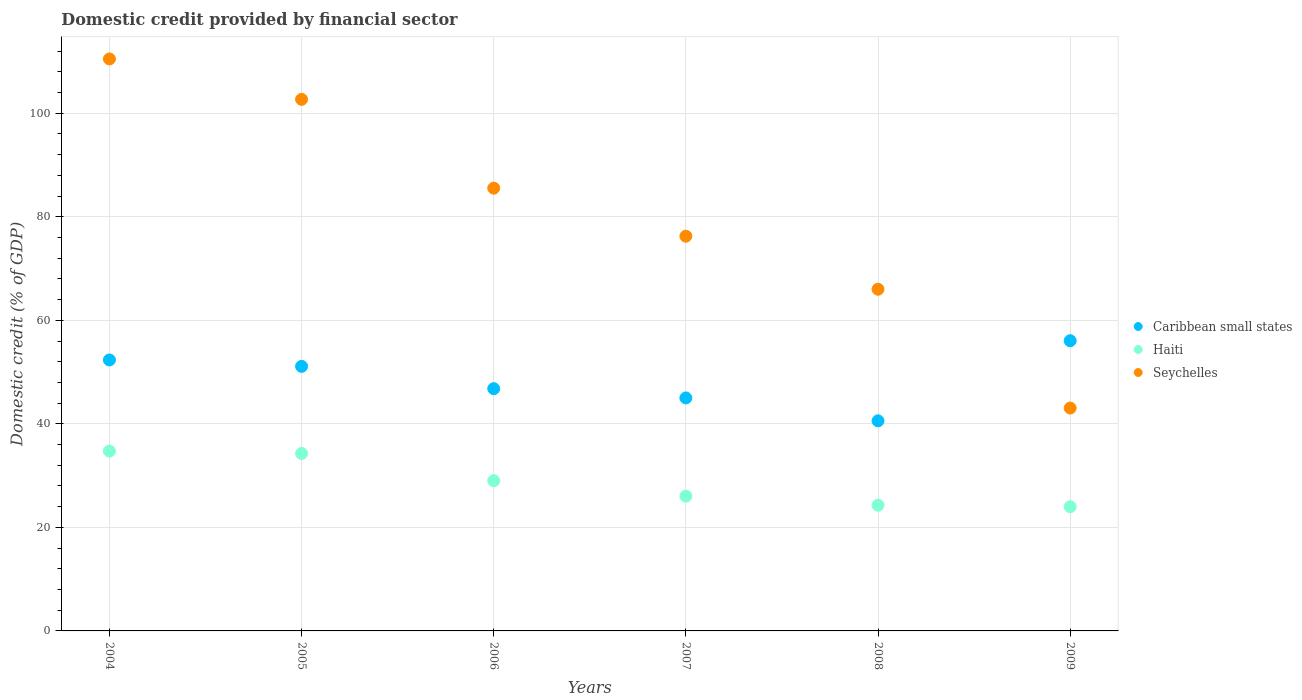What is the domestic credit in Seychelles in 2009?
Offer a terse response. 43.05. Across all years, what is the maximum domestic credit in Caribbean small states?
Make the answer very short. 56.06. Across all years, what is the minimum domestic credit in Caribbean small states?
Give a very brief answer. 40.58. In which year was the domestic credit in Caribbean small states maximum?
Your answer should be very brief. 2009. In which year was the domestic credit in Seychelles minimum?
Provide a succinct answer. 2009. What is the total domestic credit in Caribbean small states in the graph?
Your response must be concise. 291.91. What is the difference between the domestic credit in Caribbean small states in 2006 and that in 2009?
Make the answer very short. -9.26. What is the difference between the domestic credit in Caribbean small states in 2006 and the domestic credit in Seychelles in 2007?
Give a very brief answer. -29.45. What is the average domestic credit in Haiti per year?
Keep it short and to the point. 28.73. In the year 2008, what is the difference between the domestic credit in Seychelles and domestic credit in Caribbean small states?
Offer a very short reply. 25.42. In how many years, is the domestic credit in Haiti greater than 108 %?
Your answer should be compact. 0. What is the ratio of the domestic credit in Seychelles in 2004 to that in 2008?
Offer a terse response. 1.67. What is the difference between the highest and the second highest domestic credit in Seychelles?
Provide a short and direct response. 7.8. What is the difference between the highest and the lowest domestic credit in Haiti?
Keep it short and to the point. 10.75. Does the domestic credit in Seychelles monotonically increase over the years?
Offer a very short reply. No. Is the domestic credit in Caribbean small states strictly greater than the domestic credit in Seychelles over the years?
Make the answer very short. No. How many dotlines are there?
Keep it short and to the point. 3. How many years are there in the graph?
Offer a terse response. 6. Does the graph contain grids?
Ensure brevity in your answer.  Yes. How many legend labels are there?
Make the answer very short. 3. How are the legend labels stacked?
Make the answer very short. Vertical. What is the title of the graph?
Offer a terse response. Domestic credit provided by financial sector. What is the label or title of the Y-axis?
Make the answer very short. Domestic credit (% of GDP). What is the Domestic credit (% of GDP) of Caribbean small states in 2004?
Provide a short and direct response. 52.34. What is the Domestic credit (% of GDP) of Haiti in 2004?
Keep it short and to the point. 34.74. What is the Domestic credit (% of GDP) of Seychelles in 2004?
Ensure brevity in your answer.  110.49. What is the Domestic credit (% of GDP) of Caribbean small states in 2005?
Keep it short and to the point. 51.11. What is the Domestic credit (% of GDP) of Haiti in 2005?
Keep it short and to the point. 34.29. What is the Domestic credit (% of GDP) of Seychelles in 2005?
Provide a succinct answer. 102.69. What is the Domestic credit (% of GDP) of Caribbean small states in 2006?
Provide a succinct answer. 46.8. What is the Domestic credit (% of GDP) of Haiti in 2006?
Offer a very short reply. 29.02. What is the Domestic credit (% of GDP) of Seychelles in 2006?
Give a very brief answer. 85.53. What is the Domestic credit (% of GDP) in Caribbean small states in 2007?
Your answer should be very brief. 45.01. What is the Domestic credit (% of GDP) in Haiti in 2007?
Ensure brevity in your answer.  26.04. What is the Domestic credit (% of GDP) in Seychelles in 2007?
Give a very brief answer. 76.25. What is the Domestic credit (% of GDP) of Caribbean small states in 2008?
Provide a short and direct response. 40.58. What is the Domestic credit (% of GDP) in Haiti in 2008?
Your answer should be compact. 24.28. What is the Domestic credit (% of GDP) in Seychelles in 2008?
Your answer should be compact. 66. What is the Domestic credit (% of GDP) in Caribbean small states in 2009?
Ensure brevity in your answer.  56.06. What is the Domestic credit (% of GDP) of Haiti in 2009?
Ensure brevity in your answer.  24. What is the Domestic credit (% of GDP) in Seychelles in 2009?
Give a very brief answer. 43.05. Across all years, what is the maximum Domestic credit (% of GDP) of Caribbean small states?
Offer a terse response. 56.06. Across all years, what is the maximum Domestic credit (% of GDP) of Haiti?
Your response must be concise. 34.74. Across all years, what is the maximum Domestic credit (% of GDP) of Seychelles?
Your answer should be very brief. 110.49. Across all years, what is the minimum Domestic credit (% of GDP) of Caribbean small states?
Your answer should be very brief. 40.58. Across all years, what is the minimum Domestic credit (% of GDP) in Haiti?
Your answer should be compact. 24. Across all years, what is the minimum Domestic credit (% of GDP) in Seychelles?
Keep it short and to the point. 43.05. What is the total Domestic credit (% of GDP) of Caribbean small states in the graph?
Your answer should be compact. 291.91. What is the total Domestic credit (% of GDP) in Haiti in the graph?
Offer a terse response. 172.36. What is the total Domestic credit (% of GDP) of Seychelles in the graph?
Your answer should be compact. 484.02. What is the difference between the Domestic credit (% of GDP) of Caribbean small states in 2004 and that in 2005?
Offer a terse response. 1.24. What is the difference between the Domestic credit (% of GDP) of Haiti in 2004 and that in 2005?
Make the answer very short. 0.46. What is the difference between the Domestic credit (% of GDP) in Seychelles in 2004 and that in 2005?
Provide a short and direct response. 7.8. What is the difference between the Domestic credit (% of GDP) of Caribbean small states in 2004 and that in 2006?
Keep it short and to the point. 5.54. What is the difference between the Domestic credit (% of GDP) in Haiti in 2004 and that in 2006?
Make the answer very short. 5.72. What is the difference between the Domestic credit (% of GDP) in Seychelles in 2004 and that in 2006?
Provide a succinct answer. 24.96. What is the difference between the Domestic credit (% of GDP) of Caribbean small states in 2004 and that in 2007?
Provide a succinct answer. 7.34. What is the difference between the Domestic credit (% of GDP) in Haiti in 2004 and that in 2007?
Your answer should be very brief. 8.71. What is the difference between the Domestic credit (% of GDP) in Seychelles in 2004 and that in 2007?
Make the answer very short. 34.24. What is the difference between the Domestic credit (% of GDP) of Caribbean small states in 2004 and that in 2008?
Your answer should be compact. 11.76. What is the difference between the Domestic credit (% of GDP) of Haiti in 2004 and that in 2008?
Offer a terse response. 10.47. What is the difference between the Domestic credit (% of GDP) in Seychelles in 2004 and that in 2008?
Provide a succinct answer. 44.49. What is the difference between the Domestic credit (% of GDP) of Caribbean small states in 2004 and that in 2009?
Your response must be concise. -3.72. What is the difference between the Domestic credit (% of GDP) in Haiti in 2004 and that in 2009?
Provide a succinct answer. 10.75. What is the difference between the Domestic credit (% of GDP) in Seychelles in 2004 and that in 2009?
Your answer should be very brief. 67.44. What is the difference between the Domestic credit (% of GDP) in Caribbean small states in 2005 and that in 2006?
Offer a very short reply. 4.31. What is the difference between the Domestic credit (% of GDP) in Haiti in 2005 and that in 2006?
Offer a terse response. 5.26. What is the difference between the Domestic credit (% of GDP) of Seychelles in 2005 and that in 2006?
Offer a terse response. 17.16. What is the difference between the Domestic credit (% of GDP) of Caribbean small states in 2005 and that in 2007?
Keep it short and to the point. 6.1. What is the difference between the Domestic credit (% of GDP) in Haiti in 2005 and that in 2007?
Provide a short and direct response. 8.25. What is the difference between the Domestic credit (% of GDP) in Seychelles in 2005 and that in 2007?
Keep it short and to the point. 26.44. What is the difference between the Domestic credit (% of GDP) in Caribbean small states in 2005 and that in 2008?
Offer a very short reply. 10.52. What is the difference between the Domestic credit (% of GDP) of Haiti in 2005 and that in 2008?
Offer a very short reply. 10.01. What is the difference between the Domestic credit (% of GDP) in Seychelles in 2005 and that in 2008?
Offer a terse response. 36.69. What is the difference between the Domestic credit (% of GDP) in Caribbean small states in 2005 and that in 2009?
Provide a succinct answer. -4.96. What is the difference between the Domestic credit (% of GDP) of Haiti in 2005 and that in 2009?
Make the answer very short. 10.29. What is the difference between the Domestic credit (% of GDP) of Seychelles in 2005 and that in 2009?
Your response must be concise. 59.64. What is the difference between the Domestic credit (% of GDP) in Caribbean small states in 2006 and that in 2007?
Make the answer very short. 1.79. What is the difference between the Domestic credit (% of GDP) in Haiti in 2006 and that in 2007?
Offer a very short reply. 2.99. What is the difference between the Domestic credit (% of GDP) of Seychelles in 2006 and that in 2007?
Ensure brevity in your answer.  9.28. What is the difference between the Domestic credit (% of GDP) of Caribbean small states in 2006 and that in 2008?
Give a very brief answer. 6.22. What is the difference between the Domestic credit (% of GDP) of Haiti in 2006 and that in 2008?
Provide a short and direct response. 4.75. What is the difference between the Domestic credit (% of GDP) in Seychelles in 2006 and that in 2008?
Offer a terse response. 19.53. What is the difference between the Domestic credit (% of GDP) in Caribbean small states in 2006 and that in 2009?
Ensure brevity in your answer.  -9.26. What is the difference between the Domestic credit (% of GDP) in Haiti in 2006 and that in 2009?
Your answer should be very brief. 5.03. What is the difference between the Domestic credit (% of GDP) of Seychelles in 2006 and that in 2009?
Provide a succinct answer. 42.48. What is the difference between the Domestic credit (% of GDP) of Caribbean small states in 2007 and that in 2008?
Offer a terse response. 4.42. What is the difference between the Domestic credit (% of GDP) in Haiti in 2007 and that in 2008?
Make the answer very short. 1.76. What is the difference between the Domestic credit (% of GDP) in Seychelles in 2007 and that in 2008?
Your answer should be very brief. 10.25. What is the difference between the Domestic credit (% of GDP) in Caribbean small states in 2007 and that in 2009?
Provide a succinct answer. -11.06. What is the difference between the Domestic credit (% of GDP) in Haiti in 2007 and that in 2009?
Keep it short and to the point. 2.04. What is the difference between the Domestic credit (% of GDP) in Seychelles in 2007 and that in 2009?
Provide a succinct answer. 33.2. What is the difference between the Domestic credit (% of GDP) in Caribbean small states in 2008 and that in 2009?
Provide a short and direct response. -15.48. What is the difference between the Domestic credit (% of GDP) of Haiti in 2008 and that in 2009?
Your answer should be very brief. 0.28. What is the difference between the Domestic credit (% of GDP) in Seychelles in 2008 and that in 2009?
Your answer should be compact. 22.95. What is the difference between the Domestic credit (% of GDP) of Caribbean small states in 2004 and the Domestic credit (% of GDP) of Haiti in 2005?
Give a very brief answer. 18.06. What is the difference between the Domestic credit (% of GDP) of Caribbean small states in 2004 and the Domestic credit (% of GDP) of Seychelles in 2005?
Offer a very short reply. -50.35. What is the difference between the Domestic credit (% of GDP) of Haiti in 2004 and the Domestic credit (% of GDP) of Seychelles in 2005?
Keep it short and to the point. -67.95. What is the difference between the Domestic credit (% of GDP) of Caribbean small states in 2004 and the Domestic credit (% of GDP) of Haiti in 2006?
Your answer should be compact. 23.32. What is the difference between the Domestic credit (% of GDP) of Caribbean small states in 2004 and the Domestic credit (% of GDP) of Seychelles in 2006?
Your answer should be compact. -33.19. What is the difference between the Domestic credit (% of GDP) of Haiti in 2004 and the Domestic credit (% of GDP) of Seychelles in 2006?
Your response must be concise. -50.79. What is the difference between the Domestic credit (% of GDP) in Caribbean small states in 2004 and the Domestic credit (% of GDP) in Haiti in 2007?
Make the answer very short. 26.31. What is the difference between the Domestic credit (% of GDP) of Caribbean small states in 2004 and the Domestic credit (% of GDP) of Seychelles in 2007?
Ensure brevity in your answer.  -23.91. What is the difference between the Domestic credit (% of GDP) of Haiti in 2004 and the Domestic credit (% of GDP) of Seychelles in 2007?
Provide a succinct answer. -41.51. What is the difference between the Domestic credit (% of GDP) in Caribbean small states in 2004 and the Domestic credit (% of GDP) in Haiti in 2008?
Your answer should be compact. 28.07. What is the difference between the Domestic credit (% of GDP) of Caribbean small states in 2004 and the Domestic credit (% of GDP) of Seychelles in 2008?
Give a very brief answer. -13.66. What is the difference between the Domestic credit (% of GDP) of Haiti in 2004 and the Domestic credit (% of GDP) of Seychelles in 2008?
Offer a very short reply. -31.26. What is the difference between the Domestic credit (% of GDP) of Caribbean small states in 2004 and the Domestic credit (% of GDP) of Haiti in 2009?
Offer a terse response. 28.35. What is the difference between the Domestic credit (% of GDP) in Caribbean small states in 2004 and the Domestic credit (% of GDP) in Seychelles in 2009?
Make the answer very short. 9.29. What is the difference between the Domestic credit (% of GDP) of Haiti in 2004 and the Domestic credit (% of GDP) of Seychelles in 2009?
Make the answer very short. -8.31. What is the difference between the Domestic credit (% of GDP) of Caribbean small states in 2005 and the Domestic credit (% of GDP) of Haiti in 2006?
Provide a succinct answer. 22.08. What is the difference between the Domestic credit (% of GDP) of Caribbean small states in 2005 and the Domestic credit (% of GDP) of Seychelles in 2006?
Provide a short and direct response. -34.42. What is the difference between the Domestic credit (% of GDP) of Haiti in 2005 and the Domestic credit (% of GDP) of Seychelles in 2006?
Ensure brevity in your answer.  -51.25. What is the difference between the Domestic credit (% of GDP) in Caribbean small states in 2005 and the Domestic credit (% of GDP) in Haiti in 2007?
Provide a succinct answer. 25.07. What is the difference between the Domestic credit (% of GDP) of Caribbean small states in 2005 and the Domestic credit (% of GDP) of Seychelles in 2007?
Give a very brief answer. -25.14. What is the difference between the Domestic credit (% of GDP) in Haiti in 2005 and the Domestic credit (% of GDP) in Seychelles in 2007?
Your answer should be compact. -41.97. What is the difference between the Domestic credit (% of GDP) in Caribbean small states in 2005 and the Domestic credit (% of GDP) in Haiti in 2008?
Your response must be concise. 26.83. What is the difference between the Domestic credit (% of GDP) of Caribbean small states in 2005 and the Domestic credit (% of GDP) of Seychelles in 2008?
Provide a succinct answer. -14.9. What is the difference between the Domestic credit (% of GDP) in Haiti in 2005 and the Domestic credit (% of GDP) in Seychelles in 2008?
Offer a terse response. -31.72. What is the difference between the Domestic credit (% of GDP) in Caribbean small states in 2005 and the Domestic credit (% of GDP) in Haiti in 2009?
Give a very brief answer. 27.11. What is the difference between the Domestic credit (% of GDP) in Caribbean small states in 2005 and the Domestic credit (% of GDP) in Seychelles in 2009?
Your answer should be compact. 8.05. What is the difference between the Domestic credit (% of GDP) of Haiti in 2005 and the Domestic credit (% of GDP) of Seychelles in 2009?
Your response must be concise. -8.77. What is the difference between the Domestic credit (% of GDP) in Caribbean small states in 2006 and the Domestic credit (% of GDP) in Haiti in 2007?
Give a very brief answer. 20.77. What is the difference between the Domestic credit (% of GDP) of Caribbean small states in 2006 and the Domestic credit (% of GDP) of Seychelles in 2007?
Provide a short and direct response. -29.45. What is the difference between the Domestic credit (% of GDP) of Haiti in 2006 and the Domestic credit (% of GDP) of Seychelles in 2007?
Ensure brevity in your answer.  -47.23. What is the difference between the Domestic credit (% of GDP) in Caribbean small states in 2006 and the Domestic credit (% of GDP) in Haiti in 2008?
Offer a very short reply. 22.53. What is the difference between the Domestic credit (% of GDP) of Caribbean small states in 2006 and the Domestic credit (% of GDP) of Seychelles in 2008?
Your response must be concise. -19.2. What is the difference between the Domestic credit (% of GDP) in Haiti in 2006 and the Domestic credit (% of GDP) in Seychelles in 2008?
Provide a short and direct response. -36.98. What is the difference between the Domestic credit (% of GDP) in Caribbean small states in 2006 and the Domestic credit (% of GDP) in Haiti in 2009?
Ensure brevity in your answer.  22.81. What is the difference between the Domestic credit (% of GDP) of Caribbean small states in 2006 and the Domestic credit (% of GDP) of Seychelles in 2009?
Offer a terse response. 3.75. What is the difference between the Domestic credit (% of GDP) of Haiti in 2006 and the Domestic credit (% of GDP) of Seychelles in 2009?
Your answer should be compact. -14.03. What is the difference between the Domestic credit (% of GDP) in Caribbean small states in 2007 and the Domestic credit (% of GDP) in Haiti in 2008?
Your answer should be very brief. 20.73. What is the difference between the Domestic credit (% of GDP) of Caribbean small states in 2007 and the Domestic credit (% of GDP) of Seychelles in 2008?
Make the answer very short. -21. What is the difference between the Domestic credit (% of GDP) in Haiti in 2007 and the Domestic credit (% of GDP) in Seychelles in 2008?
Offer a very short reply. -39.97. What is the difference between the Domestic credit (% of GDP) in Caribbean small states in 2007 and the Domestic credit (% of GDP) in Haiti in 2009?
Provide a succinct answer. 21.01. What is the difference between the Domestic credit (% of GDP) in Caribbean small states in 2007 and the Domestic credit (% of GDP) in Seychelles in 2009?
Your answer should be compact. 1.95. What is the difference between the Domestic credit (% of GDP) in Haiti in 2007 and the Domestic credit (% of GDP) in Seychelles in 2009?
Your response must be concise. -17.02. What is the difference between the Domestic credit (% of GDP) in Caribbean small states in 2008 and the Domestic credit (% of GDP) in Haiti in 2009?
Offer a terse response. 16.59. What is the difference between the Domestic credit (% of GDP) of Caribbean small states in 2008 and the Domestic credit (% of GDP) of Seychelles in 2009?
Offer a very short reply. -2.47. What is the difference between the Domestic credit (% of GDP) of Haiti in 2008 and the Domestic credit (% of GDP) of Seychelles in 2009?
Your answer should be very brief. -18.78. What is the average Domestic credit (% of GDP) of Caribbean small states per year?
Give a very brief answer. 48.65. What is the average Domestic credit (% of GDP) of Haiti per year?
Offer a very short reply. 28.73. What is the average Domestic credit (% of GDP) in Seychelles per year?
Keep it short and to the point. 80.67. In the year 2004, what is the difference between the Domestic credit (% of GDP) in Caribbean small states and Domestic credit (% of GDP) in Haiti?
Your response must be concise. 17.6. In the year 2004, what is the difference between the Domestic credit (% of GDP) of Caribbean small states and Domestic credit (% of GDP) of Seychelles?
Offer a terse response. -58.15. In the year 2004, what is the difference between the Domestic credit (% of GDP) of Haiti and Domestic credit (% of GDP) of Seychelles?
Keep it short and to the point. -75.75. In the year 2005, what is the difference between the Domestic credit (% of GDP) of Caribbean small states and Domestic credit (% of GDP) of Haiti?
Keep it short and to the point. 16.82. In the year 2005, what is the difference between the Domestic credit (% of GDP) in Caribbean small states and Domestic credit (% of GDP) in Seychelles?
Keep it short and to the point. -51.59. In the year 2005, what is the difference between the Domestic credit (% of GDP) of Haiti and Domestic credit (% of GDP) of Seychelles?
Ensure brevity in your answer.  -68.41. In the year 2006, what is the difference between the Domestic credit (% of GDP) of Caribbean small states and Domestic credit (% of GDP) of Haiti?
Ensure brevity in your answer.  17.78. In the year 2006, what is the difference between the Domestic credit (% of GDP) of Caribbean small states and Domestic credit (% of GDP) of Seychelles?
Keep it short and to the point. -38.73. In the year 2006, what is the difference between the Domestic credit (% of GDP) in Haiti and Domestic credit (% of GDP) in Seychelles?
Your response must be concise. -56.51. In the year 2007, what is the difference between the Domestic credit (% of GDP) in Caribbean small states and Domestic credit (% of GDP) in Haiti?
Your answer should be compact. 18.97. In the year 2007, what is the difference between the Domestic credit (% of GDP) in Caribbean small states and Domestic credit (% of GDP) in Seychelles?
Ensure brevity in your answer.  -31.24. In the year 2007, what is the difference between the Domestic credit (% of GDP) of Haiti and Domestic credit (% of GDP) of Seychelles?
Provide a short and direct response. -50.22. In the year 2008, what is the difference between the Domestic credit (% of GDP) in Caribbean small states and Domestic credit (% of GDP) in Haiti?
Make the answer very short. 16.31. In the year 2008, what is the difference between the Domestic credit (% of GDP) in Caribbean small states and Domestic credit (% of GDP) in Seychelles?
Your answer should be compact. -25.42. In the year 2008, what is the difference between the Domestic credit (% of GDP) of Haiti and Domestic credit (% of GDP) of Seychelles?
Ensure brevity in your answer.  -41.73. In the year 2009, what is the difference between the Domestic credit (% of GDP) in Caribbean small states and Domestic credit (% of GDP) in Haiti?
Give a very brief answer. 32.07. In the year 2009, what is the difference between the Domestic credit (% of GDP) of Caribbean small states and Domestic credit (% of GDP) of Seychelles?
Your answer should be compact. 13.01. In the year 2009, what is the difference between the Domestic credit (% of GDP) in Haiti and Domestic credit (% of GDP) in Seychelles?
Your answer should be very brief. -19.06. What is the ratio of the Domestic credit (% of GDP) in Caribbean small states in 2004 to that in 2005?
Your answer should be very brief. 1.02. What is the ratio of the Domestic credit (% of GDP) in Haiti in 2004 to that in 2005?
Give a very brief answer. 1.01. What is the ratio of the Domestic credit (% of GDP) of Seychelles in 2004 to that in 2005?
Provide a succinct answer. 1.08. What is the ratio of the Domestic credit (% of GDP) of Caribbean small states in 2004 to that in 2006?
Provide a short and direct response. 1.12. What is the ratio of the Domestic credit (% of GDP) in Haiti in 2004 to that in 2006?
Your answer should be compact. 1.2. What is the ratio of the Domestic credit (% of GDP) of Seychelles in 2004 to that in 2006?
Provide a succinct answer. 1.29. What is the ratio of the Domestic credit (% of GDP) in Caribbean small states in 2004 to that in 2007?
Keep it short and to the point. 1.16. What is the ratio of the Domestic credit (% of GDP) in Haiti in 2004 to that in 2007?
Offer a very short reply. 1.33. What is the ratio of the Domestic credit (% of GDP) in Seychelles in 2004 to that in 2007?
Offer a terse response. 1.45. What is the ratio of the Domestic credit (% of GDP) of Caribbean small states in 2004 to that in 2008?
Make the answer very short. 1.29. What is the ratio of the Domestic credit (% of GDP) in Haiti in 2004 to that in 2008?
Offer a very short reply. 1.43. What is the ratio of the Domestic credit (% of GDP) of Seychelles in 2004 to that in 2008?
Your answer should be compact. 1.67. What is the ratio of the Domestic credit (% of GDP) in Caribbean small states in 2004 to that in 2009?
Give a very brief answer. 0.93. What is the ratio of the Domestic credit (% of GDP) in Haiti in 2004 to that in 2009?
Your answer should be very brief. 1.45. What is the ratio of the Domestic credit (% of GDP) of Seychelles in 2004 to that in 2009?
Keep it short and to the point. 2.57. What is the ratio of the Domestic credit (% of GDP) in Caribbean small states in 2005 to that in 2006?
Ensure brevity in your answer.  1.09. What is the ratio of the Domestic credit (% of GDP) in Haiti in 2005 to that in 2006?
Keep it short and to the point. 1.18. What is the ratio of the Domestic credit (% of GDP) in Seychelles in 2005 to that in 2006?
Give a very brief answer. 1.2. What is the ratio of the Domestic credit (% of GDP) of Caribbean small states in 2005 to that in 2007?
Ensure brevity in your answer.  1.14. What is the ratio of the Domestic credit (% of GDP) in Haiti in 2005 to that in 2007?
Make the answer very short. 1.32. What is the ratio of the Domestic credit (% of GDP) in Seychelles in 2005 to that in 2007?
Your answer should be compact. 1.35. What is the ratio of the Domestic credit (% of GDP) in Caribbean small states in 2005 to that in 2008?
Offer a terse response. 1.26. What is the ratio of the Domestic credit (% of GDP) of Haiti in 2005 to that in 2008?
Provide a succinct answer. 1.41. What is the ratio of the Domestic credit (% of GDP) of Seychelles in 2005 to that in 2008?
Your answer should be very brief. 1.56. What is the ratio of the Domestic credit (% of GDP) of Caribbean small states in 2005 to that in 2009?
Offer a terse response. 0.91. What is the ratio of the Domestic credit (% of GDP) of Haiti in 2005 to that in 2009?
Offer a very short reply. 1.43. What is the ratio of the Domestic credit (% of GDP) in Seychelles in 2005 to that in 2009?
Ensure brevity in your answer.  2.39. What is the ratio of the Domestic credit (% of GDP) of Caribbean small states in 2006 to that in 2007?
Your answer should be compact. 1.04. What is the ratio of the Domestic credit (% of GDP) of Haiti in 2006 to that in 2007?
Offer a terse response. 1.11. What is the ratio of the Domestic credit (% of GDP) in Seychelles in 2006 to that in 2007?
Keep it short and to the point. 1.12. What is the ratio of the Domestic credit (% of GDP) in Caribbean small states in 2006 to that in 2008?
Ensure brevity in your answer.  1.15. What is the ratio of the Domestic credit (% of GDP) in Haiti in 2006 to that in 2008?
Ensure brevity in your answer.  1.2. What is the ratio of the Domestic credit (% of GDP) of Seychelles in 2006 to that in 2008?
Give a very brief answer. 1.3. What is the ratio of the Domestic credit (% of GDP) of Caribbean small states in 2006 to that in 2009?
Your response must be concise. 0.83. What is the ratio of the Domestic credit (% of GDP) in Haiti in 2006 to that in 2009?
Your answer should be very brief. 1.21. What is the ratio of the Domestic credit (% of GDP) of Seychelles in 2006 to that in 2009?
Offer a very short reply. 1.99. What is the ratio of the Domestic credit (% of GDP) of Caribbean small states in 2007 to that in 2008?
Give a very brief answer. 1.11. What is the ratio of the Domestic credit (% of GDP) in Haiti in 2007 to that in 2008?
Ensure brevity in your answer.  1.07. What is the ratio of the Domestic credit (% of GDP) in Seychelles in 2007 to that in 2008?
Ensure brevity in your answer.  1.16. What is the ratio of the Domestic credit (% of GDP) in Caribbean small states in 2007 to that in 2009?
Offer a terse response. 0.8. What is the ratio of the Domestic credit (% of GDP) in Haiti in 2007 to that in 2009?
Provide a succinct answer. 1.09. What is the ratio of the Domestic credit (% of GDP) of Seychelles in 2007 to that in 2009?
Provide a short and direct response. 1.77. What is the ratio of the Domestic credit (% of GDP) in Caribbean small states in 2008 to that in 2009?
Offer a very short reply. 0.72. What is the ratio of the Domestic credit (% of GDP) in Haiti in 2008 to that in 2009?
Provide a succinct answer. 1.01. What is the ratio of the Domestic credit (% of GDP) in Seychelles in 2008 to that in 2009?
Offer a very short reply. 1.53. What is the difference between the highest and the second highest Domestic credit (% of GDP) of Caribbean small states?
Ensure brevity in your answer.  3.72. What is the difference between the highest and the second highest Domestic credit (% of GDP) in Haiti?
Provide a short and direct response. 0.46. What is the difference between the highest and the second highest Domestic credit (% of GDP) in Seychelles?
Offer a very short reply. 7.8. What is the difference between the highest and the lowest Domestic credit (% of GDP) of Caribbean small states?
Give a very brief answer. 15.48. What is the difference between the highest and the lowest Domestic credit (% of GDP) of Haiti?
Your answer should be compact. 10.75. What is the difference between the highest and the lowest Domestic credit (% of GDP) of Seychelles?
Ensure brevity in your answer.  67.44. 